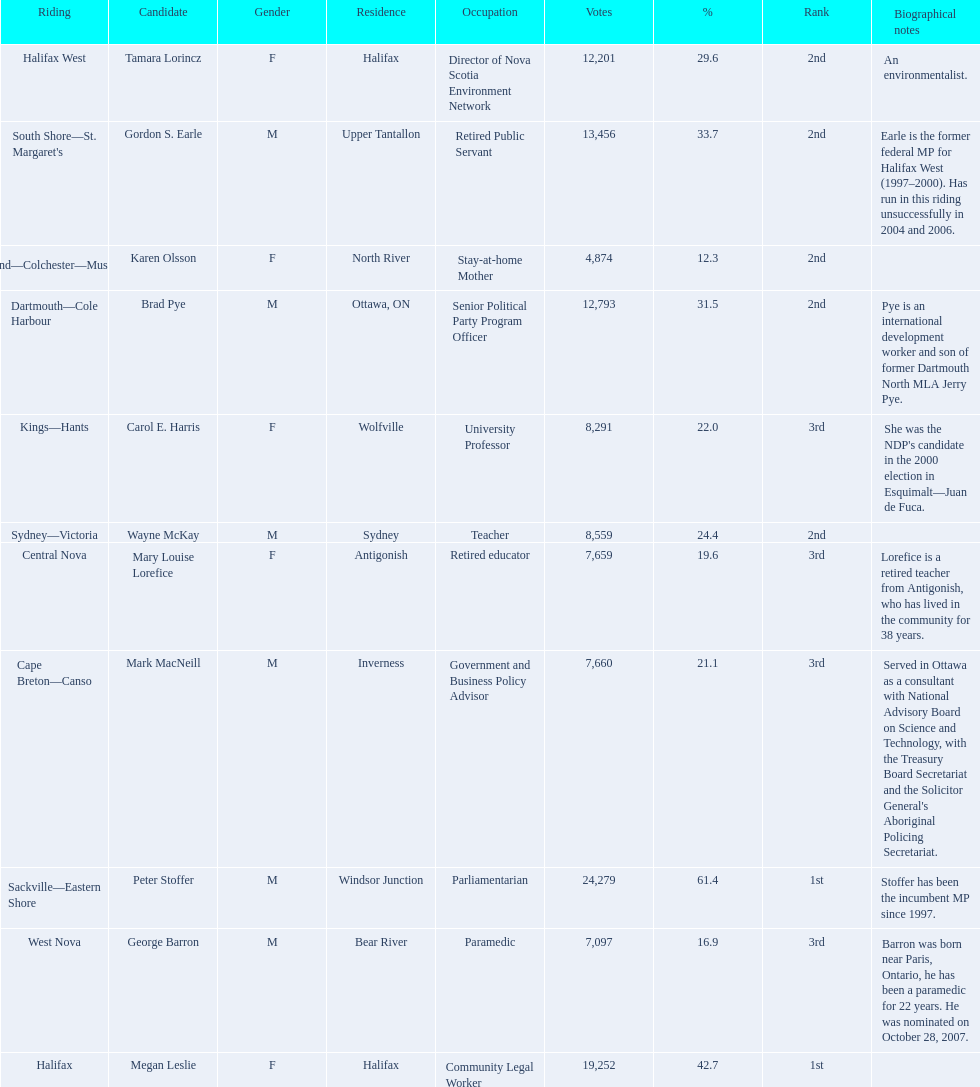Who were the new democratic party candidates, 2008? Mark MacNeill, Mary Louise Lorefice, Karen Olsson, Brad Pye, Megan Leslie, Tamara Lorincz, Carol E. Harris, Peter Stoffer, Gordon S. Earle, Wayne McKay, George Barron. Who had the 2nd highest number of votes? Megan Leslie, Peter Stoffer. How many votes did she receive? 19,252. 